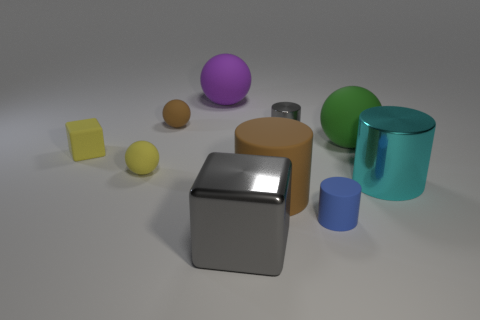Subtract all large green balls. How many balls are left? 3 Subtract all cylinders. How many objects are left? 6 Subtract 0 red balls. How many objects are left? 10 Subtract 3 cylinders. How many cylinders are left? 1 Subtract all purple spheres. Subtract all blue cylinders. How many spheres are left? 3 Subtract all gray spheres. How many gray cylinders are left? 1 Subtract all metal cylinders. Subtract all brown matte cylinders. How many objects are left? 7 Add 2 large cyan metal cylinders. How many large cyan metal cylinders are left? 3 Add 9 large green cylinders. How many large green cylinders exist? 9 Subtract all yellow blocks. How many blocks are left? 1 